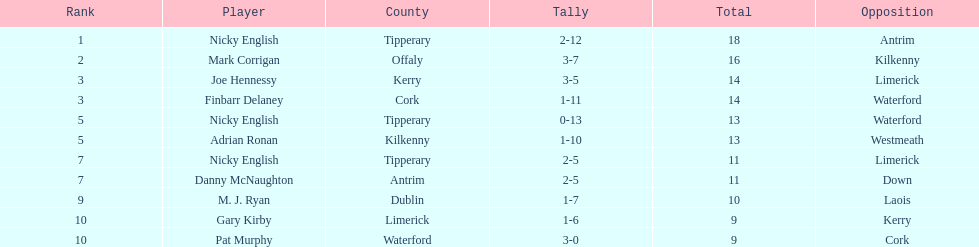What was the aggregate amount of nicky english and mark corrigan? 34. 